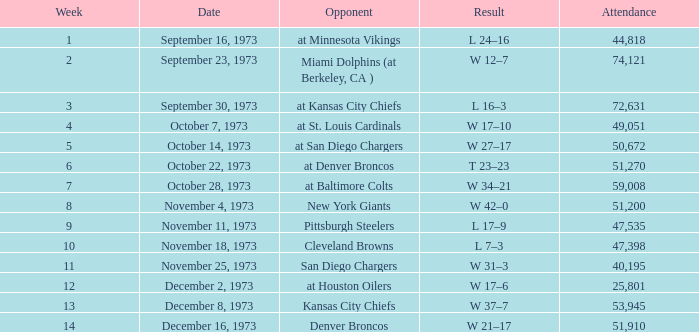Give me the full table as a dictionary. {'header': ['Week', 'Date', 'Opponent', 'Result', 'Attendance'], 'rows': [['1', 'September 16, 1973', 'at Minnesota Vikings', 'L 24–16', '44,818'], ['2', 'September 23, 1973', 'Miami Dolphins (at Berkeley, CA )', 'W 12–7', '74,121'], ['3', 'September 30, 1973', 'at Kansas City Chiefs', 'L 16–3', '72,631'], ['4', 'October 7, 1973', 'at St. Louis Cardinals', 'W 17–10', '49,051'], ['5', 'October 14, 1973', 'at San Diego Chargers', 'W 27–17', '50,672'], ['6', 'October 22, 1973', 'at Denver Broncos', 'T 23–23', '51,270'], ['7', 'October 28, 1973', 'at Baltimore Colts', 'W 34–21', '59,008'], ['8', 'November 4, 1973', 'New York Giants', 'W 42–0', '51,200'], ['9', 'November 11, 1973', 'Pittsburgh Steelers', 'L 17–9', '47,535'], ['10', 'November 18, 1973', 'Cleveland Browns', 'L 7–3', '47,398'], ['11', 'November 25, 1973', 'San Diego Chargers', 'W 31–3', '40,195'], ['12', 'December 2, 1973', 'at Houston Oilers', 'W 17–6', '25,801'], ['13', 'December 8, 1973', 'Kansas City Chiefs', 'W 37–7', '53,945'], ['14', 'December 16, 1973', 'Denver Broncos', 'W 21–17', '51,910']]} What is the presence for the game versus the kansas city chiefs earlier than week 13? None. 